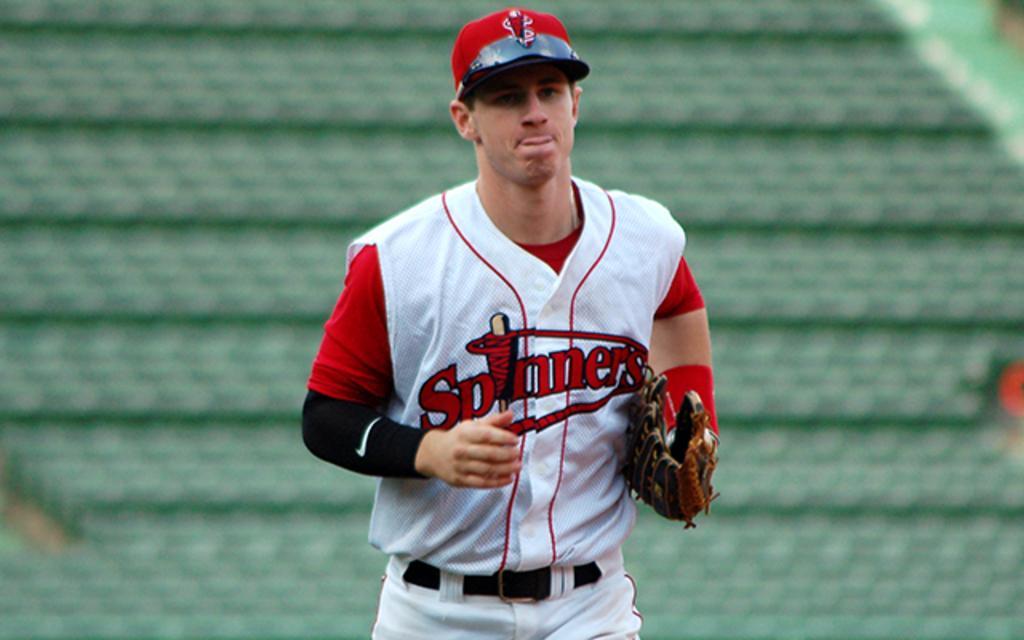How would you summarize this image in a sentence or two? In this image, I can see a person standing with a cap, clothes and a glove. There is a blurred background. 